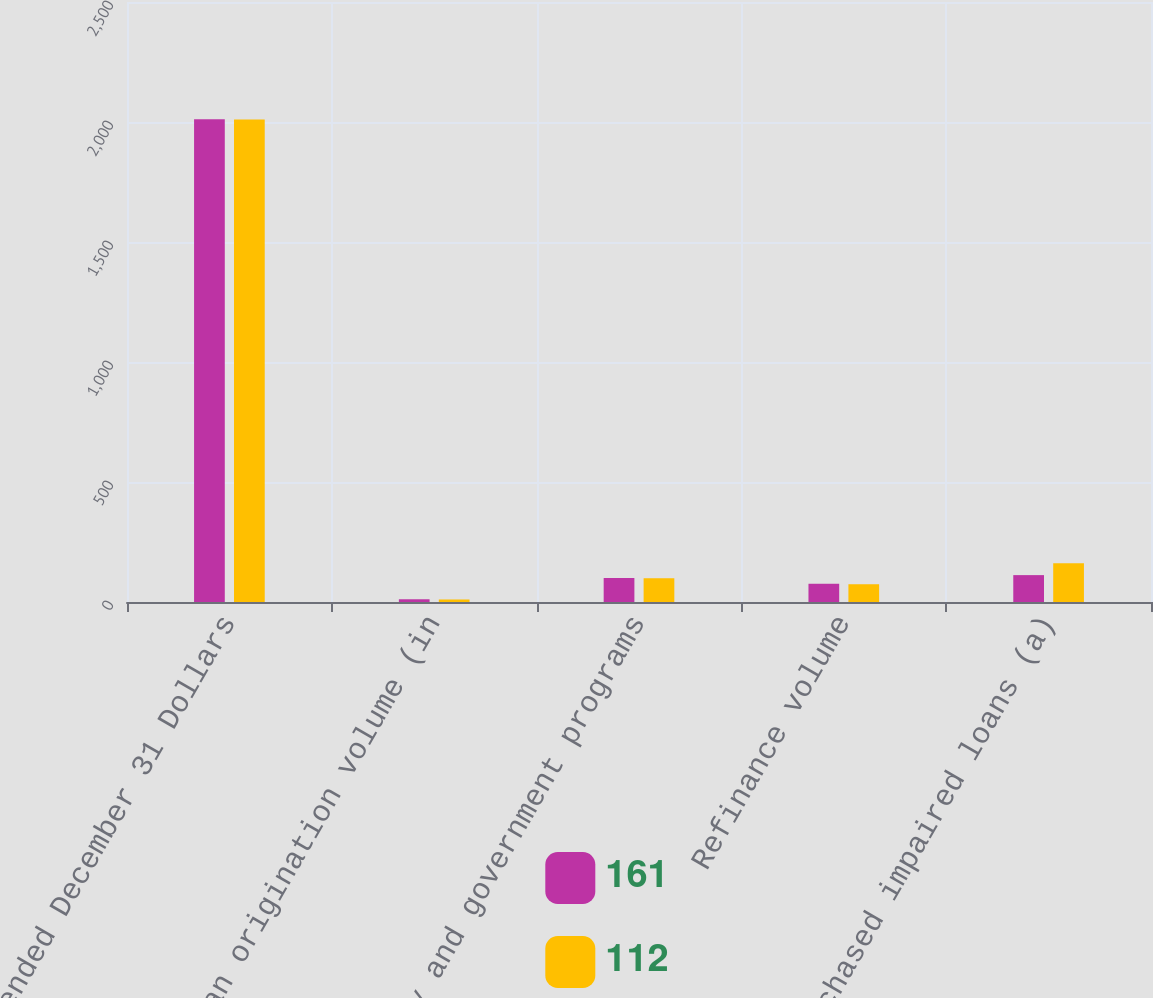<chart> <loc_0><loc_0><loc_500><loc_500><stacked_bar_chart><ecel><fcel>Year ended December 31 Dollars<fcel>Loan origination volume (in<fcel>Agency and government programs<fcel>Refinance volume<fcel>Purchased impaired loans (a)<nl><fcel>161<fcel>2011<fcel>11.4<fcel>100<fcel>76<fcel>112<nl><fcel>112<fcel>2010<fcel>10.5<fcel>99<fcel>74<fcel>161<nl></chart> 